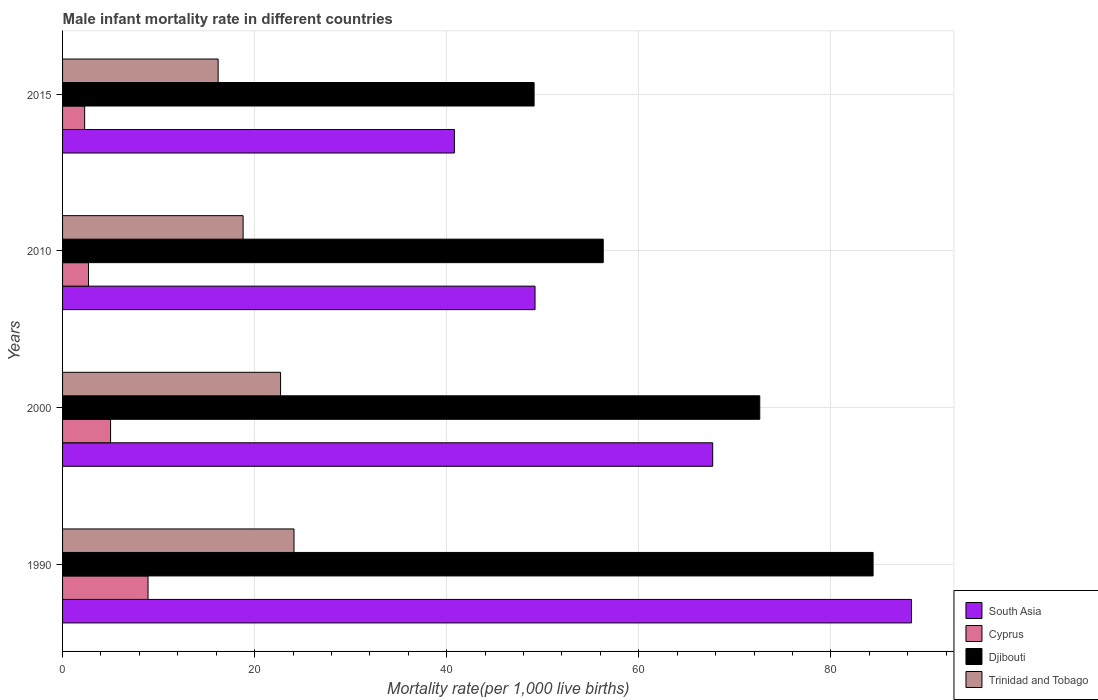Are the number of bars per tick equal to the number of legend labels?
Offer a terse response. Yes. How many bars are there on the 2nd tick from the top?
Your response must be concise. 4. In how many cases, is the number of bars for a given year not equal to the number of legend labels?
Give a very brief answer. 0. What is the male infant mortality rate in South Asia in 2015?
Ensure brevity in your answer.  40.8. Across all years, what is the maximum male infant mortality rate in South Asia?
Offer a terse response. 88.4. In which year was the male infant mortality rate in Trinidad and Tobago maximum?
Provide a short and direct response. 1990. In which year was the male infant mortality rate in Trinidad and Tobago minimum?
Offer a very short reply. 2015. What is the total male infant mortality rate in Cyprus in the graph?
Provide a succinct answer. 18.9. What is the difference between the male infant mortality rate in Djibouti in 1990 and that in 2010?
Your answer should be compact. 28.1. What is the difference between the male infant mortality rate in Trinidad and Tobago in 2010 and the male infant mortality rate in South Asia in 2015?
Give a very brief answer. -22. What is the average male infant mortality rate in South Asia per year?
Your answer should be very brief. 61.53. In the year 2010, what is the difference between the male infant mortality rate in Cyprus and male infant mortality rate in South Asia?
Provide a succinct answer. -46.5. What is the ratio of the male infant mortality rate in Djibouti in 2000 to that in 2015?
Your answer should be compact. 1.48. What is the difference between the highest and the second highest male infant mortality rate in Cyprus?
Your answer should be very brief. 3.9. What is the difference between the highest and the lowest male infant mortality rate in Trinidad and Tobago?
Your answer should be compact. 7.9. In how many years, is the male infant mortality rate in Djibouti greater than the average male infant mortality rate in Djibouti taken over all years?
Keep it short and to the point. 2. What does the 1st bar from the top in 2015 represents?
Ensure brevity in your answer.  Trinidad and Tobago. What does the 4th bar from the bottom in 1990 represents?
Provide a short and direct response. Trinidad and Tobago. What is the difference between two consecutive major ticks on the X-axis?
Provide a succinct answer. 20. Where does the legend appear in the graph?
Give a very brief answer. Bottom right. What is the title of the graph?
Provide a short and direct response. Male infant mortality rate in different countries. Does "Italy" appear as one of the legend labels in the graph?
Give a very brief answer. No. What is the label or title of the X-axis?
Provide a succinct answer. Mortality rate(per 1,0 live births). What is the Mortality rate(per 1,000 live births) of South Asia in 1990?
Your response must be concise. 88.4. What is the Mortality rate(per 1,000 live births) in Cyprus in 1990?
Keep it short and to the point. 8.9. What is the Mortality rate(per 1,000 live births) of Djibouti in 1990?
Ensure brevity in your answer.  84.4. What is the Mortality rate(per 1,000 live births) of Trinidad and Tobago in 1990?
Your answer should be compact. 24.1. What is the Mortality rate(per 1,000 live births) of South Asia in 2000?
Keep it short and to the point. 67.7. What is the Mortality rate(per 1,000 live births) in Cyprus in 2000?
Keep it short and to the point. 5. What is the Mortality rate(per 1,000 live births) of Djibouti in 2000?
Ensure brevity in your answer.  72.6. What is the Mortality rate(per 1,000 live births) of Trinidad and Tobago in 2000?
Offer a very short reply. 22.7. What is the Mortality rate(per 1,000 live births) in South Asia in 2010?
Provide a succinct answer. 49.2. What is the Mortality rate(per 1,000 live births) of Cyprus in 2010?
Offer a terse response. 2.7. What is the Mortality rate(per 1,000 live births) of Djibouti in 2010?
Your response must be concise. 56.3. What is the Mortality rate(per 1,000 live births) in Trinidad and Tobago in 2010?
Your answer should be very brief. 18.8. What is the Mortality rate(per 1,000 live births) of South Asia in 2015?
Provide a short and direct response. 40.8. What is the Mortality rate(per 1,000 live births) of Djibouti in 2015?
Your answer should be compact. 49.1. What is the Mortality rate(per 1,000 live births) of Trinidad and Tobago in 2015?
Provide a short and direct response. 16.2. Across all years, what is the maximum Mortality rate(per 1,000 live births) of South Asia?
Keep it short and to the point. 88.4. Across all years, what is the maximum Mortality rate(per 1,000 live births) of Djibouti?
Your answer should be compact. 84.4. Across all years, what is the maximum Mortality rate(per 1,000 live births) in Trinidad and Tobago?
Offer a terse response. 24.1. Across all years, what is the minimum Mortality rate(per 1,000 live births) of South Asia?
Make the answer very short. 40.8. Across all years, what is the minimum Mortality rate(per 1,000 live births) in Cyprus?
Provide a short and direct response. 2.3. Across all years, what is the minimum Mortality rate(per 1,000 live births) in Djibouti?
Provide a short and direct response. 49.1. What is the total Mortality rate(per 1,000 live births) of South Asia in the graph?
Your response must be concise. 246.1. What is the total Mortality rate(per 1,000 live births) of Cyprus in the graph?
Provide a short and direct response. 18.9. What is the total Mortality rate(per 1,000 live births) in Djibouti in the graph?
Offer a very short reply. 262.4. What is the total Mortality rate(per 1,000 live births) in Trinidad and Tobago in the graph?
Provide a succinct answer. 81.8. What is the difference between the Mortality rate(per 1,000 live births) in South Asia in 1990 and that in 2000?
Your answer should be very brief. 20.7. What is the difference between the Mortality rate(per 1,000 live births) of Cyprus in 1990 and that in 2000?
Ensure brevity in your answer.  3.9. What is the difference between the Mortality rate(per 1,000 live births) in Trinidad and Tobago in 1990 and that in 2000?
Ensure brevity in your answer.  1.4. What is the difference between the Mortality rate(per 1,000 live births) of South Asia in 1990 and that in 2010?
Keep it short and to the point. 39.2. What is the difference between the Mortality rate(per 1,000 live births) of Djibouti in 1990 and that in 2010?
Your response must be concise. 28.1. What is the difference between the Mortality rate(per 1,000 live births) in South Asia in 1990 and that in 2015?
Your answer should be compact. 47.6. What is the difference between the Mortality rate(per 1,000 live births) of Djibouti in 1990 and that in 2015?
Provide a short and direct response. 35.3. What is the difference between the Mortality rate(per 1,000 live births) in Trinidad and Tobago in 1990 and that in 2015?
Keep it short and to the point. 7.9. What is the difference between the Mortality rate(per 1,000 live births) in Djibouti in 2000 and that in 2010?
Ensure brevity in your answer.  16.3. What is the difference between the Mortality rate(per 1,000 live births) of South Asia in 2000 and that in 2015?
Your answer should be compact. 26.9. What is the difference between the Mortality rate(per 1,000 live births) of Cyprus in 2000 and that in 2015?
Your answer should be compact. 2.7. What is the difference between the Mortality rate(per 1,000 live births) of Djibouti in 2000 and that in 2015?
Keep it short and to the point. 23.5. What is the difference between the Mortality rate(per 1,000 live births) of Djibouti in 2010 and that in 2015?
Your response must be concise. 7.2. What is the difference between the Mortality rate(per 1,000 live births) of Trinidad and Tobago in 2010 and that in 2015?
Your answer should be very brief. 2.6. What is the difference between the Mortality rate(per 1,000 live births) in South Asia in 1990 and the Mortality rate(per 1,000 live births) in Cyprus in 2000?
Your response must be concise. 83.4. What is the difference between the Mortality rate(per 1,000 live births) of South Asia in 1990 and the Mortality rate(per 1,000 live births) of Djibouti in 2000?
Your answer should be very brief. 15.8. What is the difference between the Mortality rate(per 1,000 live births) in South Asia in 1990 and the Mortality rate(per 1,000 live births) in Trinidad and Tobago in 2000?
Make the answer very short. 65.7. What is the difference between the Mortality rate(per 1,000 live births) in Cyprus in 1990 and the Mortality rate(per 1,000 live births) in Djibouti in 2000?
Make the answer very short. -63.7. What is the difference between the Mortality rate(per 1,000 live births) of Cyprus in 1990 and the Mortality rate(per 1,000 live births) of Trinidad and Tobago in 2000?
Make the answer very short. -13.8. What is the difference between the Mortality rate(per 1,000 live births) in Djibouti in 1990 and the Mortality rate(per 1,000 live births) in Trinidad and Tobago in 2000?
Offer a very short reply. 61.7. What is the difference between the Mortality rate(per 1,000 live births) in South Asia in 1990 and the Mortality rate(per 1,000 live births) in Cyprus in 2010?
Ensure brevity in your answer.  85.7. What is the difference between the Mortality rate(per 1,000 live births) of South Asia in 1990 and the Mortality rate(per 1,000 live births) of Djibouti in 2010?
Offer a very short reply. 32.1. What is the difference between the Mortality rate(per 1,000 live births) of South Asia in 1990 and the Mortality rate(per 1,000 live births) of Trinidad and Tobago in 2010?
Your answer should be very brief. 69.6. What is the difference between the Mortality rate(per 1,000 live births) of Cyprus in 1990 and the Mortality rate(per 1,000 live births) of Djibouti in 2010?
Keep it short and to the point. -47.4. What is the difference between the Mortality rate(per 1,000 live births) of Cyprus in 1990 and the Mortality rate(per 1,000 live births) of Trinidad and Tobago in 2010?
Give a very brief answer. -9.9. What is the difference between the Mortality rate(per 1,000 live births) in Djibouti in 1990 and the Mortality rate(per 1,000 live births) in Trinidad and Tobago in 2010?
Your answer should be compact. 65.6. What is the difference between the Mortality rate(per 1,000 live births) in South Asia in 1990 and the Mortality rate(per 1,000 live births) in Cyprus in 2015?
Provide a short and direct response. 86.1. What is the difference between the Mortality rate(per 1,000 live births) of South Asia in 1990 and the Mortality rate(per 1,000 live births) of Djibouti in 2015?
Your answer should be very brief. 39.3. What is the difference between the Mortality rate(per 1,000 live births) in South Asia in 1990 and the Mortality rate(per 1,000 live births) in Trinidad and Tobago in 2015?
Keep it short and to the point. 72.2. What is the difference between the Mortality rate(per 1,000 live births) of Cyprus in 1990 and the Mortality rate(per 1,000 live births) of Djibouti in 2015?
Provide a succinct answer. -40.2. What is the difference between the Mortality rate(per 1,000 live births) of Cyprus in 1990 and the Mortality rate(per 1,000 live births) of Trinidad and Tobago in 2015?
Offer a terse response. -7.3. What is the difference between the Mortality rate(per 1,000 live births) in Djibouti in 1990 and the Mortality rate(per 1,000 live births) in Trinidad and Tobago in 2015?
Offer a terse response. 68.2. What is the difference between the Mortality rate(per 1,000 live births) of South Asia in 2000 and the Mortality rate(per 1,000 live births) of Trinidad and Tobago in 2010?
Keep it short and to the point. 48.9. What is the difference between the Mortality rate(per 1,000 live births) in Cyprus in 2000 and the Mortality rate(per 1,000 live births) in Djibouti in 2010?
Make the answer very short. -51.3. What is the difference between the Mortality rate(per 1,000 live births) of Djibouti in 2000 and the Mortality rate(per 1,000 live births) of Trinidad and Tobago in 2010?
Your response must be concise. 53.8. What is the difference between the Mortality rate(per 1,000 live births) in South Asia in 2000 and the Mortality rate(per 1,000 live births) in Cyprus in 2015?
Your response must be concise. 65.4. What is the difference between the Mortality rate(per 1,000 live births) in South Asia in 2000 and the Mortality rate(per 1,000 live births) in Djibouti in 2015?
Keep it short and to the point. 18.6. What is the difference between the Mortality rate(per 1,000 live births) of South Asia in 2000 and the Mortality rate(per 1,000 live births) of Trinidad and Tobago in 2015?
Offer a very short reply. 51.5. What is the difference between the Mortality rate(per 1,000 live births) in Cyprus in 2000 and the Mortality rate(per 1,000 live births) in Djibouti in 2015?
Keep it short and to the point. -44.1. What is the difference between the Mortality rate(per 1,000 live births) in Cyprus in 2000 and the Mortality rate(per 1,000 live births) in Trinidad and Tobago in 2015?
Your answer should be very brief. -11.2. What is the difference between the Mortality rate(per 1,000 live births) of Djibouti in 2000 and the Mortality rate(per 1,000 live births) of Trinidad and Tobago in 2015?
Keep it short and to the point. 56.4. What is the difference between the Mortality rate(per 1,000 live births) in South Asia in 2010 and the Mortality rate(per 1,000 live births) in Cyprus in 2015?
Offer a terse response. 46.9. What is the difference between the Mortality rate(per 1,000 live births) of Cyprus in 2010 and the Mortality rate(per 1,000 live births) of Djibouti in 2015?
Make the answer very short. -46.4. What is the difference between the Mortality rate(per 1,000 live births) of Djibouti in 2010 and the Mortality rate(per 1,000 live births) of Trinidad and Tobago in 2015?
Offer a terse response. 40.1. What is the average Mortality rate(per 1,000 live births) of South Asia per year?
Provide a short and direct response. 61.52. What is the average Mortality rate(per 1,000 live births) in Cyprus per year?
Provide a succinct answer. 4.72. What is the average Mortality rate(per 1,000 live births) of Djibouti per year?
Your answer should be very brief. 65.6. What is the average Mortality rate(per 1,000 live births) of Trinidad and Tobago per year?
Provide a short and direct response. 20.45. In the year 1990, what is the difference between the Mortality rate(per 1,000 live births) of South Asia and Mortality rate(per 1,000 live births) of Cyprus?
Your answer should be compact. 79.5. In the year 1990, what is the difference between the Mortality rate(per 1,000 live births) of South Asia and Mortality rate(per 1,000 live births) of Djibouti?
Keep it short and to the point. 4. In the year 1990, what is the difference between the Mortality rate(per 1,000 live births) in South Asia and Mortality rate(per 1,000 live births) in Trinidad and Tobago?
Ensure brevity in your answer.  64.3. In the year 1990, what is the difference between the Mortality rate(per 1,000 live births) of Cyprus and Mortality rate(per 1,000 live births) of Djibouti?
Offer a terse response. -75.5. In the year 1990, what is the difference between the Mortality rate(per 1,000 live births) in Cyprus and Mortality rate(per 1,000 live births) in Trinidad and Tobago?
Your answer should be compact. -15.2. In the year 1990, what is the difference between the Mortality rate(per 1,000 live births) in Djibouti and Mortality rate(per 1,000 live births) in Trinidad and Tobago?
Your response must be concise. 60.3. In the year 2000, what is the difference between the Mortality rate(per 1,000 live births) in South Asia and Mortality rate(per 1,000 live births) in Cyprus?
Ensure brevity in your answer.  62.7. In the year 2000, what is the difference between the Mortality rate(per 1,000 live births) of South Asia and Mortality rate(per 1,000 live births) of Trinidad and Tobago?
Offer a terse response. 45. In the year 2000, what is the difference between the Mortality rate(per 1,000 live births) in Cyprus and Mortality rate(per 1,000 live births) in Djibouti?
Your answer should be very brief. -67.6. In the year 2000, what is the difference between the Mortality rate(per 1,000 live births) of Cyprus and Mortality rate(per 1,000 live births) of Trinidad and Tobago?
Provide a short and direct response. -17.7. In the year 2000, what is the difference between the Mortality rate(per 1,000 live births) in Djibouti and Mortality rate(per 1,000 live births) in Trinidad and Tobago?
Offer a very short reply. 49.9. In the year 2010, what is the difference between the Mortality rate(per 1,000 live births) in South Asia and Mortality rate(per 1,000 live births) in Cyprus?
Your answer should be compact. 46.5. In the year 2010, what is the difference between the Mortality rate(per 1,000 live births) in South Asia and Mortality rate(per 1,000 live births) in Trinidad and Tobago?
Provide a short and direct response. 30.4. In the year 2010, what is the difference between the Mortality rate(per 1,000 live births) of Cyprus and Mortality rate(per 1,000 live births) of Djibouti?
Keep it short and to the point. -53.6. In the year 2010, what is the difference between the Mortality rate(per 1,000 live births) in Cyprus and Mortality rate(per 1,000 live births) in Trinidad and Tobago?
Your answer should be very brief. -16.1. In the year 2010, what is the difference between the Mortality rate(per 1,000 live births) of Djibouti and Mortality rate(per 1,000 live births) of Trinidad and Tobago?
Your response must be concise. 37.5. In the year 2015, what is the difference between the Mortality rate(per 1,000 live births) in South Asia and Mortality rate(per 1,000 live births) in Cyprus?
Keep it short and to the point. 38.5. In the year 2015, what is the difference between the Mortality rate(per 1,000 live births) of South Asia and Mortality rate(per 1,000 live births) of Djibouti?
Offer a very short reply. -8.3. In the year 2015, what is the difference between the Mortality rate(per 1,000 live births) in South Asia and Mortality rate(per 1,000 live births) in Trinidad and Tobago?
Make the answer very short. 24.6. In the year 2015, what is the difference between the Mortality rate(per 1,000 live births) of Cyprus and Mortality rate(per 1,000 live births) of Djibouti?
Provide a short and direct response. -46.8. In the year 2015, what is the difference between the Mortality rate(per 1,000 live births) in Cyprus and Mortality rate(per 1,000 live births) in Trinidad and Tobago?
Offer a terse response. -13.9. In the year 2015, what is the difference between the Mortality rate(per 1,000 live births) in Djibouti and Mortality rate(per 1,000 live births) in Trinidad and Tobago?
Your response must be concise. 32.9. What is the ratio of the Mortality rate(per 1,000 live births) of South Asia in 1990 to that in 2000?
Keep it short and to the point. 1.31. What is the ratio of the Mortality rate(per 1,000 live births) of Cyprus in 1990 to that in 2000?
Your answer should be compact. 1.78. What is the ratio of the Mortality rate(per 1,000 live births) in Djibouti in 1990 to that in 2000?
Provide a succinct answer. 1.16. What is the ratio of the Mortality rate(per 1,000 live births) in Trinidad and Tobago in 1990 to that in 2000?
Your response must be concise. 1.06. What is the ratio of the Mortality rate(per 1,000 live births) of South Asia in 1990 to that in 2010?
Provide a short and direct response. 1.8. What is the ratio of the Mortality rate(per 1,000 live births) of Cyprus in 1990 to that in 2010?
Offer a very short reply. 3.3. What is the ratio of the Mortality rate(per 1,000 live births) of Djibouti in 1990 to that in 2010?
Give a very brief answer. 1.5. What is the ratio of the Mortality rate(per 1,000 live births) of Trinidad and Tobago in 1990 to that in 2010?
Offer a very short reply. 1.28. What is the ratio of the Mortality rate(per 1,000 live births) in South Asia in 1990 to that in 2015?
Keep it short and to the point. 2.17. What is the ratio of the Mortality rate(per 1,000 live births) in Cyprus in 1990 to that in 2015?
Provide a short and direct response. 3.87. What is the ratio of the Mortality rate(per 1,000 live births) of Djibouti in 1990 to that in 2015?
Ensure brevity in your answer.  1.72. What is the ratio of the Mortality rate(per 1,000 live births) of Trinidad and Tobago in 1990 to that in 2015?
Your response must be concise. 1.49. What is the ratio of the Mortality rate(per 1,000 live births) of South Asia in 2000 to that in 2010?
Keep it short and to the point. 1.38. What is the ratio of the Mortality rate(per 1,000 live births) in Cyprus in 2000 to that in 2010?
Offer a very short reply. 1.85. What is the ratio of the Mortality rate(per 1,000 live births) of Djibouti in 2000 to that in 2010?
Your answer should be very brief. 1.29. What is the ratio of the Mortality rate(per 1,000 live births) of Trinidad and Tobago in 2000 to that in 2010?
Give a very brief answer. 1.21. What is the ratio of the Mortality rate(per 1,000 live births) of South Asia in 2000 to that in 2015?
Ensure brevity in your answer.  1.66. What is the ratio of the Mortality rate(per 1,000 live births) in Cyprus in 2000 to that in 2015?
Ensure brevity in your answer.  2.17. What is the ratio of the Mortality rate(per 1,000 live births) in Djibouti in 2000 to that in 2015?
Provide a succinct answer. 1.48. What is the ratio of the Mortality rate(per 1,000 live births) of Trinidad and Tobago in 2000 to that in 2015?
Provide a short and direct response. 1.4. What is the ratio of the Mortality rate(per 1,000 live births) in South Asia in 2010 to that in 2015?
Your answer should be very brief. 1.21. What is the ratio of the Mortality rate(per 1,000 live births) in Cyprus in 2010 to that in 2015?
Your response must be concise. 1.17. What is the ratio of the Mortality rate(per 1,000 live births) in Djibouti in 2010 to that in 2015?
Ensure brevity in your answer.  1.15. What is the ratio of the Mortality rate(per 1,000 live births) of Trinidad and Tobago in 2010 to that in 2015?
Ensure brevity in your answer.  1.16. What is the difference between the highest and the second highest Mortality rate(per 1,000 live births) in South Asia?
Offer a terse response. 20.7. What is the difference between the highest and the second highest Mortality rate(per 1,000 live births) in Cyprus?
Give a very brief answer. 3.9. What is the difference between the highest and the second highest Mortality rate(per 1,000 live births) of Trinidad and Tobago?
Offer a terse response. 1.4. What is the difference between the highest and the lowest Mortality rate(per 1,000 live births) of South Asia?
Offer a terse response. 47.6. What is the difference between the highest and the lowest Mortality rate(per 1,000 live births) in Cyprus?
Provide a short and direct response. 6.6. What is the difference between the highest and the lowest Mortality rate(per 1,000 live births) in Djibouti?
Provide a short and direct response. 35.3. What is the difference between the highest and the lowest Mortality rate(per 1,000 live births) in Trinidad and Tobago?
Offer a terse response. 7.9. 